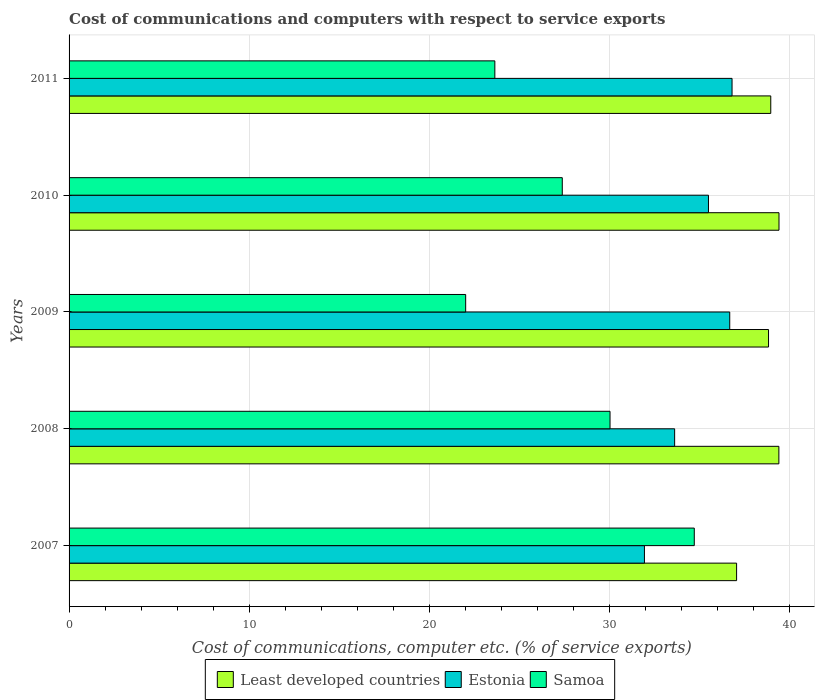How many different coloured bars are there?
Offer a very short reply. 3. Are the number of bars per tick equal to the number of legend labels?
Keep it short and to the point. Yes. Are the number of bars on each tick of the Y-axis equal?
Provide a succinct answer. Yes. What is the cost of communications and computers in Least developed countries in 2010?
Your answer should be compact. 39.4. Across all years, what is the maximum cost of communications and computers in Samoa?
Your answer should be very brief. 34.7. Across all years, what is the minimum cost of communications and computers in Samoa?
Give a very brief answer. 22.01. In which year was the cost of communications and computers in Least developed countries minimum?
Make the answer very short. 2007. What is the total cost of communications and computers in Least developed countries in the graph?
Offer a very short reply. 193.61. What is the difference between the cost of communications and computers in Samoa in 2009 and that in 2011?
Make the answer very short. -1.62. What is the difference between the cost of communications and computers in Estonia in 2009 and the cost of communications and computers in Least developed countries in 2007?
Give a very brief answer. -0.38. What is the average cost of communications and computers in Estonia per year?
Keep it short and to the point. 34.9. In the year 2008, what is the difference between the cost of communications and computers in Least developed countries and cost of communications and computers in Samoa?
Keep it short and to the point. 9.37. What is the ratio of the cost of communications and computers in Estonia in 2007 to that in 2010?
Make the answer very short. 0.9. What is the difference between the highest and the second highest cost of communications and computers in Estonia?
Make the answer very short. 0.13. What is the difference between the highest and the lowest cost of communications and computers in Least developed countries?
Make the answer very short. 2.35. In how many years, is the cost of communications and computers in Samoa greater than the average cost of communications and computers in Samoa taken over all years?
Provide a short and direct response. 2. Is the sum of the cost of communications and computers in Least developed countries in 2008 and 2010 greater than the maximum cost of communications and computers in Samoa across all years?
Ensure brevity in your answer.  Yes. What does the 3rd bar from the top in 2009 represents?
Offer a terse response. Least developed countries. What does the 3rd bar from the bottom in 2009 represents?
Ensure brevity in your answer.  Samoa. Is it the case that in every year, the sum of the cost of communications and computers in Estonia and cost of communications and computers in Samoa is greater than the cost of communications and computers in Least developed countries?
Keep it short and to the point. Yes. How many bars are there?
Ensure brevity in your answer.  15. Are all the bars in the graph horizontal?
Your answer should be compact. Yes. What is the difference between two consecutive major ticks on the X-axis?
Offer a very short reply. 10. Does the graph contain grids?
Keep it short and to the point. Yes. Where does the legend appear in the graph?
Provide a short and direct response. Bottom center. How many legend labels are there?
Give a very brief answer. 3. How are the legend labels stacked?
Give a very brief answer. Horizontal. What is the title of the graph?
Make the answer very short. Cost of communications and computers with respect to service exports. What is the label or title of the X-axis?
Make the answer very short. Cost of communications, computer etc. (% of service exports). What is the Cost of communications, computer etc. (% of service exports) of Least developed countries in 2007?
Keep it short and to the point. 37.05. What is the Cost of communications, computer etc. (% of service exports) of Estonia in 2007?
Keep it short and to the point. 31.93. What is the Cost of communications, computer etc. (% of service exports) of Samoa in 2007?
Your answer should be very brief. 34.7. What is the Cost of communications, computer etc. (% of service exports) of Least developed countries in 2008?
Provide a succinct answer. 39.4. What is the Cost of communications, computer etc. (% of service exports) of Estonia in 2008?
Provide a short and direct response. 33.61. What is the Cost of communications, computer etc. (% of service exports) in Samoa in 2008?
Your response must be concise. 30.02. What is the Cost of communications, computer etc. (% of service exports) of Least developed countries in 2009?
Your answer should be compact. 38.82. What is the Cost of communications, computer etc. (% of service exports) of Estonia in 2009?
Offer a terse response. 36.67. What is the Cost of communications, computer etc. (% of service exports) of Samoa in 2009?
Your answer should be very brief. 22.01. What is the Cost of communications, computer etc. (% of service exports) in Least developed countries in 2010?
Offer a terse response. 39.4. What is the Cost of communications, computer etc. (% of service exports) in Estonia in 2010?
Offer a very short reply. 35.49. What is the Cost of communications, computer etc. (% of service exports) in Samoa in 2010?
Your answer should be very brief. 27.37. What is the Cost of communications, computer etc. (% of service exports) in Least developed countries in 2011?
Provide a succinct answer. 38.95. What is the Cost of communications, computer etc. (% of service exports) of Estonia in 2011?
Offer a very short reply. 36.8. What is the Cost of communications, computer etc. (% of service exports) in Samoa in 2011?
Make the answer very short. 23.63. Across all years, what is the maximum Cost of communications, computer etc. (% of service exports) in Least developed countries?
Provide a succinct answer. 39.4. Across all years, what is the maximum Cost of communications, computer etc. (% of service exports) in Estonia?
Ensure brevity in your answer.  36.8. Across all years, what is the maximum Cost of communications, computer etc. (% of service exports) in Samoa?
Your response must be concise. 34.7. Across all years, what is the minimum Cost of communications, computer etc. (% of service exports) in Least developed countries?
Give a very brief answer. 37.05. Across all years, what is the minimum Cost of communications, computer etc. (% of service exports) in Estonia?
Offer a very short reply. 31.93. Across all years, what is the minimum Cost of communications, computer etc. (% of service exports) in Samoa?
Your answer should be very brief. 22.01. What is the total Cost of communications, computer etc. (% of service exports) in Least developed countries in the graph?
Your response must be concise. 193.61. What is the total Cost of communications, computer etc. (% of service exports) of Estonia in the graph?
Keep it short and to the point. 174.49. What is the total Cost of communications, computer etc. (% of service exports) in Samoa in the graph?
Your answer should be very brief. 137.74. What is the difference between the Cost of communications, computer etc. (% of service exports) in Least developed countries in 2007 and that in 2008?
Offer a terse response. -2.35. What is the difference between the Cost of communications, computer etc. (% of service exports) in Estonia in 2007 and that in 2008?
Give a very brief answer. -1.68. What is the difference between the Cost of communications, computer etc. (% of service exports) in Samoa in 2007 and that in 2008?
Ensure brevity in your answer.  4.68. What is the difference between the Cost of communications, computer etc. (% of service exports) in Least developed countries in 2007 and that in 2009?
Provide a short and direct response. -1.77. What is the difference between the Cost of communications, computer etc. (% of service exports) of Estonia in 2007 and that in 2009?
Offer a terse response. -4.73. What is the difference between the Cost of communications, computer etc. (% of service exports) of Samoa in 2007 and that in 2009?
Offer a very short reply. 12.69. What is the difference between the Cost of communications, computer etc. (% of service exports) in Least developed countries in 2007 and that in 2010?
Give a very brief answer. -2.35. What is the difference between the Cost of communications, computer etc. (% of service exports) of Estonia in 2007 and that in 2010?
Provide a succinct answer. -3.55. What is the difference between the Cost of communications, computer etc. (% of service exports) in Samoa in 2007 and that in 2010?
Keep it short and to the point. 7.33. What is the difference between the Cost of communications, computer etc. (% of service exports) of Least developed countries in 2007 and that in 2011?
Keep it short and to the point. -1.9. What is the difference between the Cost of communications, computer etc. (% of service exports) in Estonia in 2007 and that in 2011?
Your response must be concise. -4.86. What is the difference between the Cost of communications, computer etc. (% of service exports) of Samoa in 2007 and that in 2011?
Your response must be concise. 11.07. What is the difference between the Cost of communications, computer etc. (% of service exports) in Least developed countries in 2008 and that in 2009?
Offer a terse response. 0.57. What is the difference between the Cost of communications, computer etc. (% of service exports) of Estonia in 2008 and that in 2009?
Provide a short and direct response. -3.06. What is the difference between the Cost of communications, computer etc. (% of service exports) in Samoa in 2008 and that in 2009?
Provide a succinct answer. 8.01. What is the difference between the Cost of communications, computer etc. (% of service exports) of Least developed countries in 2008 and that in 2010?
Your answer should be very brief. -0.01. What is the difference between the Cost of communications, computer etc. (% of service exports) in Estonia in 2008 and that in 2010?
Provide a short and direct response. -1.88. What is the difference between the Cost of communications, computer etc. (% of service exports) in Samoa in 2008 and that in 2010?
Offer a terse response. 2.65. What is the difference between the Cost of communications, computer etc. (% of service exports) in Least developed countries in 2008 and that in 2011?
Keep it short and to the point. 0.45. What is the difference between the Cost of communications, computer etc. (% of service exports) in Estonia in 2008 and that in 2011?
Your answer should be compact. -3.19. What is the difference between the Cost of communications, computer etc. (% of service exports) in Samoa in 2008 and that in 2011?
Offer a very short reply. 6.39. What is the difference between the Cost of communications, computer etc. (% of service exports) of Least developed countries in 2009 and that in 2010?
Make the answer very short. -0.58. What is the difference between the Cost of communications, computer etc. (% of service exports) in Estonia in 2009 and that in 2010?
Give a very brief answer. 1.18. What is the difference between the Cost of communications, computer etc. (% of service exports) in Samoa in 2009 and that in 2010?
Keep it short and to the point. -5.36. What is the difference between the Cost of communications, computer etc. (% of service exports) of Least developed countries in 2009 and that in 2011?
Give a very brief answer. -0.12. What is the difference between the Cost of communications, computer etc. (% of service exports) of Estonia in 2009 and that in 2011?
Provide a short and direct response. -0.13. What is the difference between the Cost of communications, computer etc. (% of service exports) in Samoa in 2009 and that in 2011?
Your answer should be compact. -1.62. What is the difference between the Cost of communications, computer etc. (% of service exports) of Least developed countries in 2010 and that in 2011?
Keep it short and to the point. 0.46. What is the difference between the Cost of communications, computer etc. (% of service exports) in Estonia in 2010 and that in 2011?
Your answer should be very brief. -1.31. What is the difference between the Cost of communications, computer etc. (% of service exports) of Samoa in 2010 and that in 2011?
Offer a very short reply. 3.74. What is the difference between the Cost of communications, computer etc. (% of service exports) of Least developed countries in 2007 and the Cost of communications, computer etc. (% of service exports) of Estonia in 2008?
Your answer should be very brief. 3.44. What is the difference between the Cost of communications, computer etc. (% of service exports) of Least developed countries in 2007 and the Cost of communications, computer etc. (% of service exports) of Samoa in 2008?
Your answer should be compact. 7.03. What is the difference between the Cost of communications, computer etc. (% of service exports) of Estonia in 2007 and the Cost of communications, computer etc. (% of service exports) of Samoa in 2008?
Make the answer very short. 1.91. What is the difference between the Cost of communications, computer etc. (% of service exports) of Least developed countries in 2007 and the Cost of communications, computer etc. (% of service exports) of Estonia in 2009?
Your answer should be compact. 0.38. What is the difference between the Cost of communications, computer etc. (% of service exports) in Least developed countries in 2007 and the Cost of communications, computer etc. (% of service exports) in Samoa in 2009?
Provide a short and direct response. 15.04. What is the difference between the Cost of communications, computer etc. (% of service exports) of Estonia in 2007 and the Cost of communications, computer etc. (% of service exports) of Samoa in 2009?
Your answer should be very brief. 9.92. What is the difference between the Cost of communications, computer etc. (% of service exports) in Least developed countries in 2007 and the Cost of communications, computer etc. (% of service exports) in Estonia in 2010?
Your response must be concise. 1.56. What is the difference between the Cost of communications, computer etc. (% of service exports) of Least developed countries in 2007 and the Cost of communications, computer etc. (% of service exports) of Samoa in 2010?
Offer a terse response. 9.68. What is the difference between the Cost of communications, computer etc. (% of service exports) of Estonia in 2007 and the Cost of communications, computer etc. (% of service exports) of Samoa in 2010?
Offer a very short reply. 4.56. What is the difference between the Cost of communications, computer etc. (% of service exports) of Least developed countries in 2007 and the Cost of communications, computer etc. (% of service exports) of Estonia in 2011?
Offer a terse response. 0.25. What is the difference between the Cost of communications, computer etc. (% of service exports) in Least developed countries in 2007 and the Cost of communications, computer etc. (% of service exports) in Samoa in 2011?
Make the answer very short. 13.42. What is the difference between the Cost of communications, computer etc. (% of service exports) in Estonia in 2007 and the Cost of communications, computer etc. (% of service exports) in Samoa in 2011?
Give a very brief answer. 8.3. What is the difference between the Cost of communications, computer etc. (% of service exports) of Least developed countries in 2008 and the Cost of communications, computer etc. (% of service exports) of Estonia in 2009?
Offer a terse response. 2.73. What is the difference between the Cost of communications, computer etc. (% of service exports) in Least developed countries in 2008 and the Cost of communications, computer etc. (% of service exports) in Samoa in 2009?
Offer a terse response. 17.38. What is the difference between the Cost of communications, computer etc. (% of service exports) of Estonia in 2008 and the Cost of communications, computer etc. (% of service exports) of Samoa in 2009?
Provide a succinct answer. 11.6. What is the difference between the Cost of communications, computer etc. (% of service exports) in Least developed countries in 2008 and the Cost of communications, computer etc. (% of service exports) in Estonia in 2010?
Offer a terse response. 3.91. What is the difference between the Cost of communications, computer etc. (% of service exports) of Least developed countries in 2008 and the Cost of communications, computer etc. (% of service exports) of Samoa in 2010?
Your answer should be compact. 12.02. What is the difference between the Cost of communications, computer etc. (% of service exports) of Estonia in 2008 and the Cost of communications, computer etc. (% of service exports) of Samoa in 2010?
Ensure brevity in your answer.  6.24. What is the difference between the Cost of communications, computer etc. (% of service exports) in Least developed countries in 2008 and the Cost of communications, computer etc. (% of service exports) in Estonia in 2011?
Provide a short and direct response. 2.6. What is the difference between the Cost of communications, computer etc. (% of service exports) of Least developed countries in 2008 and the Cost of communications, computer etc. (% of service exports) of Samoa in 2011?
Give a very brief answer. 15.76. What is the difference between the Cost of communications, computer etc. (% of service exports) of Estonia in 2008 and the Cost of communications, computer etc. (% of service exports) of Samoa in 2011?
Your answer should be compact. 9.98. What is the difference between the Cost of communications, computer etc. (% of service exports) in Least developed countries in 2009 and the Cost of communications, computer etc. (% of service exports) in Estonia in 2010?
Your answer should be very brief. 3.33. What is the difference between the Cost of communications, computer etc. (% of service exports) of Least developed countries in 2009 and the Cost of communications, computer etc. (% of service exports) of Samoa in 2010?
Make the answer very short. 11.45. What is the difference between the Cost of communications, computer etc. (% of service exports) in Estonia in 2009 and the Cost of communications, computer etc. (% of service exports) in Samoa in 2010?
Offer a very short reply. 9.29. What is the difference between the Cost of communications, computer etc. (% of service exports) in Least developed countries in 2009 and the Cost of communications, computer etc. (% of service exports) in Estonia in 2011?
Provide a short and direct response. 2.02. What is the difference between the Cost of communications, computer etc. (% of service exports) in Least developed countries in 2009 and the Cost of communications, computer etc. (% of service exports) in Samoa in 2011?
Provide a succinct answer. 15.19. What is the difference between the Cost of communications, computer etc. (% of service exports) in Estonia in 2009 and the Cost of communications, computer etc. (% of service exports) in Samoa in 2011?
Keep it short and to the point. 13.04. What is the difference between the Cost of communications, computer etc. (% of service exports) of Least developed countries in 2010 and the Cost of communications, computer etc. (% of service exports) of Estonia in 2011?
Keep it short and to the point. 2.61. What is the difference between the Cost of communications, computer etc. (% of service exports) of Least developed countries in 2010 and the Cost of communications, computer etc. (% of service exports) of Samoa in 2011?
Your answer should be very brief. 15.77. What is the difference between the Cost of communications, computer etc. (% of service exports) of Estonia in 2010 and the Cost of communications, computer etc. (% of service exports) of Samoa in 2011?
Your answer should be very brief. 11.86. What is the average Cost of communications, computer etc. (% of service exports) of Least developed countries per year?
Provide a succinct answer. 38.72. What is the average Cost of communications, computer etc. (% of service exports) in Estonia per year?
Make the answer very short. 34.9. What is the average Cost of communications, computer etc. (% of service exports) of Samoa per year?
Provide a short and direct response. 27.55. In the year 2007, what is the difference between the Cost of communications, computer etc. (% of service exports) of Least developed countries and Cost of communications, computer etc. (% of service exports) of Estonia?
Make the answer very short. 5.11. In the year 2007, what is the difference between the Cost of communications, computer etc. (% of service exports) in Least developed countries and Cost of communications, computer etc. (% of service exports) in Samoa?
Make the answer very short. 2.35. In the year 2007, what is the difference between the Cost of communications, computer etc. (% of service exports) of Estonia and Cost of communications, computer etc. (% of service exports) of Samoa?
Offer a very short reply. -2.77. In the year 2008, what is the difference between the Cost of communications, computer etc. (% of service exports) in Least developed countries and Cost of communications, computer etc. (% of service exports) in Estonia?
Provide a succinct answer. 5.79. In the year 2008, what is the difference between the Cost of communications, computer etc. (% of service exports) in Least developed countries and Cost of communications, computer etc. (% of service exports) in Samoa?
Your answer should be compact. 9.37. In the year 2008, what is the difference between the Cost of communications, computer etc. (% of service exports) in Estonia and Cost of communications, computer etc. (% of service exports) in Samoa?
Ensure brevity in your answer.  3.59. In the year 2009, what is the difference between the Cost of communications, computer etc. (% of service exports) of Least developed countries and Cost of communications, computer etc. (% of service exports) of Estonia?
Your response must be concise. 2.15. In the year 2009, what is the difference between the Cost of communications, computer etc. (% of service exports) of Least developed countries and Cost of communications, computer etc. (% of service exports) of Samoa?
Provide a succinct answer. 16.81. In the year 2009, what is the difference between the Cost of communications, computer etc. (% of service exports) of Estonia and Cost of communications, computer etc. (% of service exports) of Samoa?
Your answer should be compact. 14.66. In the year 2010, what is the difference between the Cost of communications, computer etc. (% of service exports) in Least developed countries and Cost of communications, computer etc. (% of service exports) in Estonia?
Offer a very short reply. 3.91. In the year 2010, what is the difference between the Cost of communications, computer etc. (% of service exports) of Least developed countries and Cost of communications, computer etc. (% of service exports) of Samoa?
Ensure brevity in your answer.  12.03. In the year 2010, what is the difference between the Cost of communications, computer etc. (% of service exports) in Estonia and Cost of communications, computer etc. (% of service exports) in Samoa?
Ensure brevity in your answer.  8.11. In the year 2011, what is the difference between the Cost of communications, computer etc. (% of service exports) in Least developed countries and Cost of communications, computer etc. (% of service exports) in Estonia?
Your answer should be very brief. 2.15. In the year 2011, what is the difference between the Cost of communications, computer etc. (% of service exports) in Least developed countries and Cost of communications, computer etc. (% of service exports) in Samoa?
Offer a very short reply. 15.31. In the year 2011, what is the difference between the Cost of communications, computer etc. (% of service exports) of Estonia and Cost of communications, computer etc. (% of service exports) of Samoa?
Provide a short and direct response. 13.16. What is the ratio of the Cost of communications, computer etc. (% of service exports) in Least developed countries in 2007 to that in 2008?
Your answer should be compact. 0.94. What is the ratio of the Cost of communications, computer etc. (% of service exports) in Estonia in 2007 to that in 2008?
Ensure brevity in your answer.  0.95. What is the ratio of the Cost of communications, computer etc. (% of service exports) of Samoa in 2007 to that in 2008?
Ensure brevity in your answer.  1.16. What is the ratio of the Cost of communications, computer etc. (% of service exports) of Least developed countries in 2007 to that in 2009?
Offer a very short reply. 0.95. What is the ratio of the Cost of communications, computer etc. (% of service exports) of Estonia in 2007 to that in 2009?
Your response must be concise. 0.87. What is the ratio of the Cost of communications, computer etc. (% of service exports) of Samoa in 2007 to that in 2009?
Your answer should be compact. 1.58. What is the ratio of the Cost of communications, computer etc. (% of service exports) in Least developed countries in 2007 to that in 2010?
Offer a terse response. 0.94. What is the ratio of the Cost of communications, computer etc. (% of service exports) of Estonia in 2007 to that in 2010?
Your answer should be very brief. 0.9. What is the ratio of the Cost of communications, computer etc. (% of service exports) of Samoa in 2007 to that in 2010?
Your answer should be compact. 1.27. What is the ratio of the Cost of communications, computer etc. (% of service exports) in Least developed countries in 2007 to that in 2011?
Offer a terse response. 0.95. What is the ratio of the Cost of communications, computer etc. (% of service exports) in Estonia in 2007 to that in 2011?
Offer a terse response. 0.87. What is the ratio of the Cost of communications, computer etc. (% of service exports) in Samoa in 2007 to that in 2011?
Give a very brief answer. 1.47. What is the ratio of the Cost of communications, computer etc. (% of service exports) of Least developed countries in 2008 to that in 2009?
Offer a terse response. 1.01. What is the ratio of the Cost of communications, computer etc. (% of service exports) of Estonia in 2008 to that in 2009?
Your answer should be very brief. 0.92. What is the ratio of the Cost of communications, computer etc. (% of service exports) of Samoa in 2008 to that in 2009?
Your answer should be compact. 1.36. What is the ratio of the Cost of communications, computer etc. (% of service exports) of Estonia in 2008 to that in 2010?
Provide a short and direct response. 0.95. What is the ratio of the Cost of communications, computer etc. (% of service exports) of Samoa in 2008 to that in 2010?
Your answer should be very brief. 1.1. What is the ratio of the Cost of communications, computer etc. (% of service exports) of Least developed countries in 2008 to that in 2011?
Ensure brevity in your answer.  1.01. What is the ratio of the Cost of communications, computer etc. (% of service exports) of Estonia in 2008 to that in 2011?
Ensure brevity in your answer.  0.91. What is the ratio of the Cost of communications, computer etc. (% of service exports) in Samoa in 2008 to that in 2011?
Offer a very short reply. 1.27. What is the ratio of the Cost of communications, computer etc. (% of service exports) in Samoa in 2009 to that in 2010?
Keep it short and to the point. 0.8. What is the ratio of the Cost of communications, computer etc. (% of service exports) of Samoa in 2009 to that in 2011?
Give a very brief answer. 0.93. What is the ratio of the Cost of communications, computer etc. (% of service exports) of Least developed countries in 2010 to that in 2011?
Provide a succinct answer. 1.01. What is the ratio of the Cost of communications, computer etc. (% of service exports) of Estonia in 2010 to that in 2011?
Provide a succinct answer. 0.96. What is the ratio of the Cost of communications, computer etc. (% of service exports) of Samoa in 2010 to that in 2011?
Your answer should be very brief. 1.16. What is the difference between the highest and the second highest Cost of communications, computer etc. (% of service exports) in Least developed countries?
Your answer should be very brief. 0.01. What is the difference between the highest and the second highest Cost of communications, computer etc. (% of service exports) of Estonia?
Give a very brief answer. 0.13. What is the difference between the highest and the second highest Cost of communications, computer etc. (% of service exports) of Samoa?
Your answer should be very brief. 4.68. What is the difference between the highest and the lowest Cost of communications, computer etc. (% of service exports) in Least developed countries?
Your answer should be compact. 2.35. What is the difference between the highest and the lowest Cost of communications, computer etc. (% of service exports) in Estonia?
Your answer should be compact. 4.86. What is the difference between the highest and the lowest Cost of communications, computer etc. (% of service exports) in Samoa?
Ensure brevity in your answer.  12.69. 